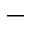<formula> <loc_0><loc_0><loc_500><loc_500>\_</formula> 